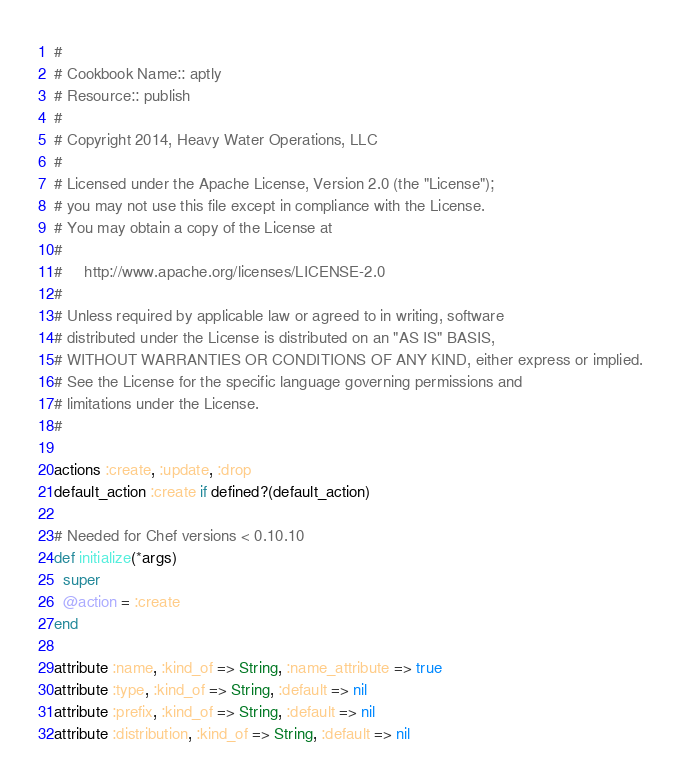<code> <loc_0><loc_0><loc_500><loc_500><_Ruby_>#
# Cookbook Name:: aptly
# Resource:: publish
#
# Copyright 2014, Heavy Water Operations, LLC
#
# Licensed under the Apache License, Version 2.0 (the "License");
# you may not use this file except in compliance with the License.
# You may obtain a copy of the License at
#
#     http://www.apache.org/licenses/LICENSE-2.0
#
# Unless required by applicable law or agreed to in writing, software
# distributed under the License is distributed on an "AS IS" BASIS,
# WITHOUT WARRANTIES OR CONDITIONS OF ANY KIND, either express or implied.
# See the License for the specific language governing permissions and
# limitations under the License.
#

actions :create, :update, :drop
default_action :create if defined?(default_action)

# Needed for Chef versions < 0.10.10
def initialize(*args)
  super
  @action = :create
end

attribute :name, :kind_of => String, :name_attribute => true
attribute :type, :kind_of => String, :default => nil
attribute :prefix, :kind_of => String, :default => nil
attribute :distribution, :kind_of => String, :default => nil

</code> 